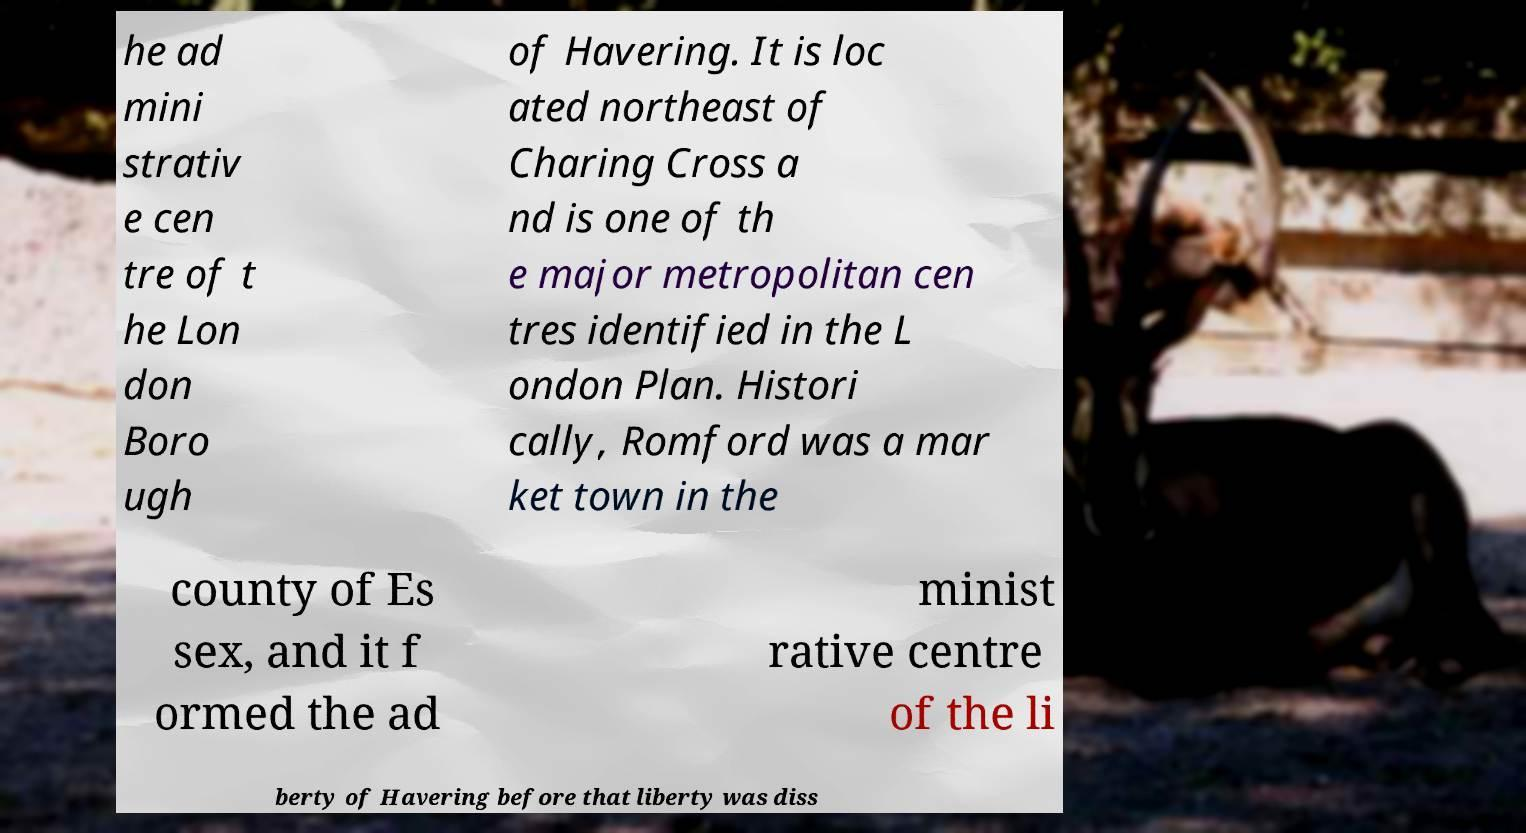I need the written content from this picture converted into text. Can you do that? he ad mini strativ e cen tre of t he Lon don Boro ugh of Havering. It is loc ated northeast of Charing Cross a nd is one of th e major metropolitan cen tres identified in the L ondon Plan. Histori cally, Romford was a mar ket town in the county of Es sex, and it f ormed the ad minist rative centre of the li berty of Havering before that liberty was diss 